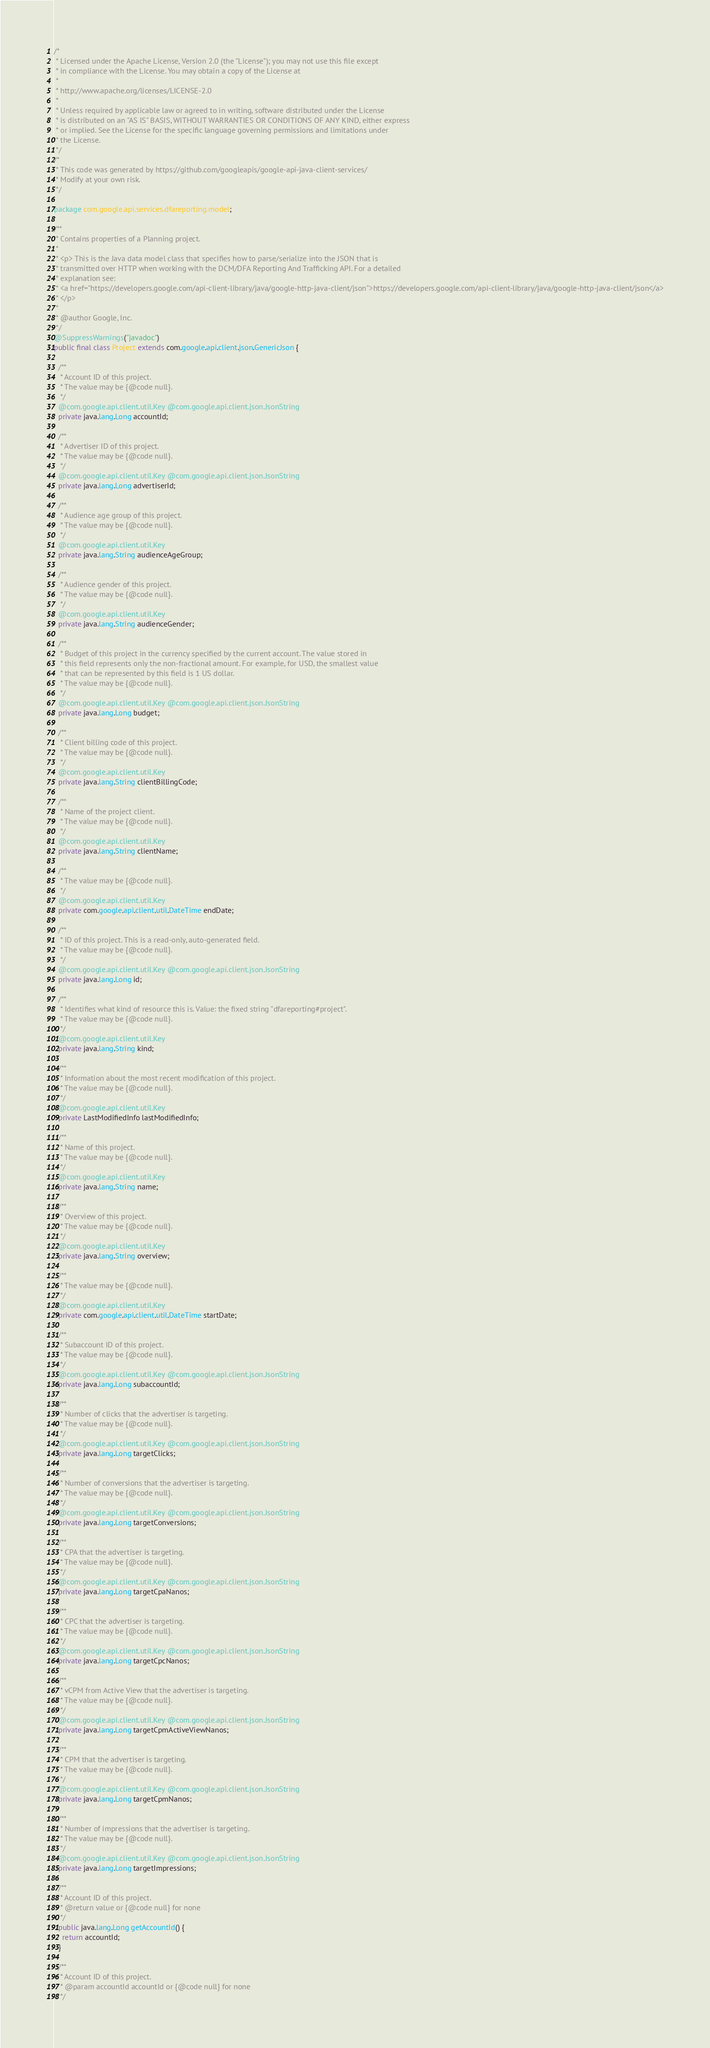<code> <loc_0><loc_0><loc_500><loc_500><_Java_>/*
 * Licensed under the Apache License, Version 2.0 (the "License"); you may not use this file except
 * in compliance with the License. You may obtain a copy of the License at
 *
 * http://www.apache.org/licenses/LICENSE-2.0
 *
 * Unless required by applicable law or agreed to in writing, software distributed under the License
 * is distributed on an "AS IS" BASIS, WITHOUT WARRANTIES OR CONDITIONS OF ANY KIND, either express
 * or implied. See the License for the specific language governing permissions and limitations under
 * the License.
 */
/*
 * This code was generated by https://github.com/googleapis/google-api-java-client-services/
 * Modify at your own risk.
 */

package com.google.api.services.dfareporting.model;

/**
 * Contains properties of a Planning project.
 *
 * <p> This is the Java data model class that specifies how to parse/serialize into the JSON that is
 * transmitted over HTTP when working with the DCM/DFA Reporting And Trafficking API. For a detailed
 * explanation see:
 * <a href="https://developers.google.com/api-client-library/java/google-http-java-client/json">https://developers.google.com/api-client-library/java/google-http-java-client/json</a>
 * </p>
 *
 * @author Google, Inc.
 */
@SuppressWarnings("javadoc")
public final class Project extends com.google.api.client.json.GenericJson {

  /**
   * Account ID of this project.
   * The value may be {@code null}.
   */
  @com.google.api.client.util.Key @com.google.api.client.json.JsonString
  private java.lang.Long accountId;

  /**
   * Advertiser ID of this project.
   * The value may be {@code null}.
   */
  @com.google.api.client.util.Key @com.google.api.client.json.JsonString
  private java.lang.Long advertiserId;

  /**
   * Audience age group of this project.
   * The value may be {@code null}.
   */
  @com.google.api.client.util.Key
  private java.lang.String audienceAgeGroup;

  /**
   * Audience gender of this project.
   * The value may be {@code null}.
   */
  @com.google.api.client.util.Key
  private java.lang.String audienceGender;

  /**
   * Budget of this project in the currency specified by the current account. The value stored in
   * this field represents only the non-fractional amount. For example, for USD, the smallest value
   * that can be represented by this field is 1 US dollar.
   * The value may be {@code null}.
   */
  @com.google.api.client.util.Key @com.google.api.client.json.JsonString
  private java.lang.Long budget;

  /**
   * Client billing code of this project.
   * The value may be {@code null}.
   */
  @com.google.api.client.util.Key
  private java.lang.String clientBillingCode;

  /**
   * Name of the project client.
   * The value may be {@code null}.
   */
  @com.google.api.client.util.Key
  private java.lang.String clientName;

  /**
   * The value may be {@code null}.
   */
  @com.google.api.client.util.Key
  private com.google.api.client.util.DateTime endDate;

  /**
   * ID of this project. This is a read-only, auto-generated field.
   * The value may be {@code null}.
   */
  @com.google.api.client.util.Key @com.google.api.client.json.JsonString
  private java.lang.Long id;

  /**
   * Identifies what kind of resource this is. Value: the fixed string "dfareporting#project".
   * The value may be {@code null}.
   */
  @com.google.api.client.util.Key
  private java.lang.String kind;

  /**
   * Information about the most recent modification of this project.
   * The value may be {@code null}.
   */
  @com.google.api.client.util.Key
  private LastModifiedInfo lastModifiedInfo;

  /**
   * Name of this project.
   * The value may be {@code null}.
   */
  @com.google.api.client.util.Key
  private java.lang.String name;

  /**
   * Overview of this project.
   * The value may be {@code null}.
   */
  @com.google.api.client.util.Key
  private java.lang.String overview;

  /**
   * The value may be {@code null}.
   */
  @com.google.api.client.util.Key
  private com.google.api.client.util.DateTime startDate;

  /**
   * Subaccount ID of this project.
   * The value may be {@code null}.
   */
  @com.google.api.client.util.Key @com.google.api.client.json.JsonString
  private java.lang.Long subaccountId;

  /**
   * Number of clicks that the advertiser is targeting.
   * The value may be {@code null}.
   */
  @com.google.api.client.util.Key @com.google.api.client.json.JsonString
  private java.lang.Long targetClicks;

  /**
   * Number of conversions that the advertiser is targeting.
   * The value may be {@code null}.
   */
  @com.google.api.client.util.Key @com.google.api.client.json.JsonString
  private java.lang.Long targetConversions;

  /**
   * CPA that the advertiser is targeting.
   * The value may be {@code null}.
   */
  @com.google.api.client.util.Key @com.google.api.client.json.JsonString
  private java.lang.Long targetCpaNanos;

  /**
   * CPC that the advertiser is targeting.
   * The value may be {@code null}.
   */
  @com.google.api.client.util.Key @com.google.api.client.json.JsonString
  private java.lang.Long targetCpcNanos;

  /**
   * vCPM from Active View that the advertiser is targeting.
   * The value may be {@code null}.
   */
  @com.google.api.client.util.Key @com.google.api.client.json.JsonString
  private java.lang.Long targetCpmActiveViewNanos;

  /**
   * CPM that the advertiser is targeting.
   * The value may be {@code null}.
   */
  @com.google.api.client.util.Key @com.google.api.client.json.JsonString
  private java.lang.Long targetCpmNanos;

  /**
   * Number of impressions that the advertiser is targeting.
   * The value may be {@code null}.
   */
  @com.google.api.client.util.Key @com.google.api.client.json.JsonString
  private java.lang.Long targetImpressions;

  /**
   * Account ID of this project.
   * @return value or {@code null} for none
   */
  public java.lang.Long getAccountId() {
    return accountId;
  }

  /**
   * Account ID of this project.
   * @param accountId accountId or {@code null} for none
   */</code> 